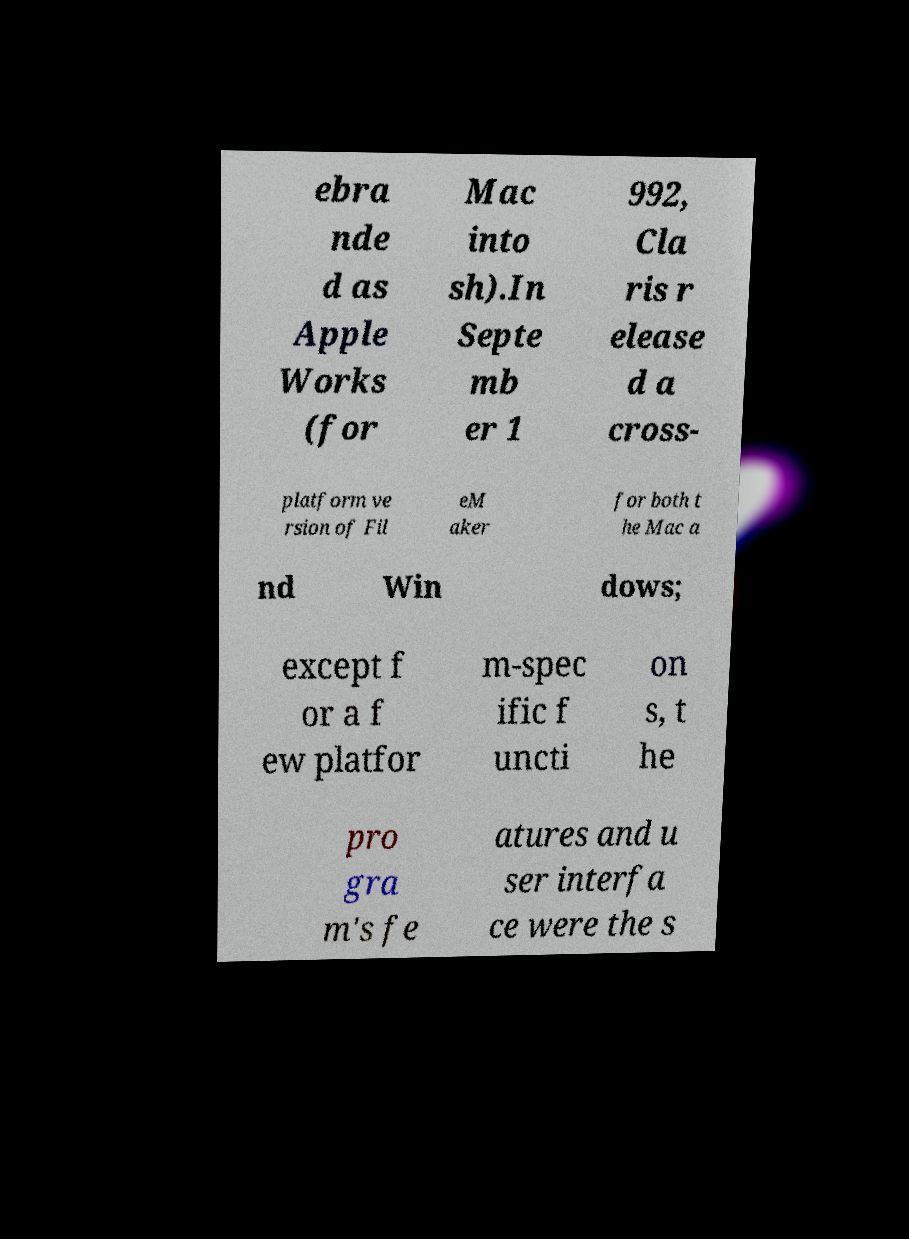Please read and relay the text visible in this image. What does it say? ebra nde d as Apple Works (for Mac into sh).In Septe mb er 1 992, Cla ris r elease d a cross- platform ve rsion of Fil eM aker for both t he Mac a nd Win dows; except f or a f ew platfor m-spec ific f uncti on s, t he pro gra m's fe atures and u ser interfa ce were the s 